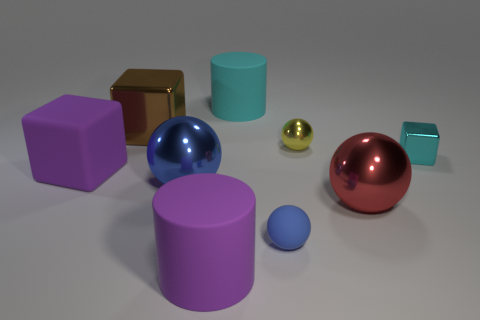What is the color of the matte ball?
Keep it short and to the point. Blue. What color is the shiny block that is to the left of the big cylinder in front of the tiny thing that is behind the tiny metallic block?
Ensure brevity in your answer.  Brown. Is the shape of the cyan matte object the same as the blue thing on the left side of the cyan rubber thing?
Your answer should be compact. No. There is a shiny object that is in front of the brown metal object and to the left of the yellow shiny ball; what is its color?
Your answer should be compact. Blue. Is there another big red thing of the same shape as the big red object?
Give a very brief answer. No. Is the big metallic block the same color as the matte cube?
Provide a succinct answer. No. Is there a matte cylinder left of the big matte thing behind the large purple cube?
Give a very brief answer. Yes. How many objects are metallic objects to the left of the blue metal object or metallic objects behind the large red object?
Make the answer very short. 4. What number of objects are either tiny cyan rubber balls or rubber cylinders behind the blue matte sphere?
Your answer should be compact. 1. There is a cyan object that is behind the yellow metal sphere behind the blue thing behind the red metal object; what size is it?
Offer a very short reply. Large. 